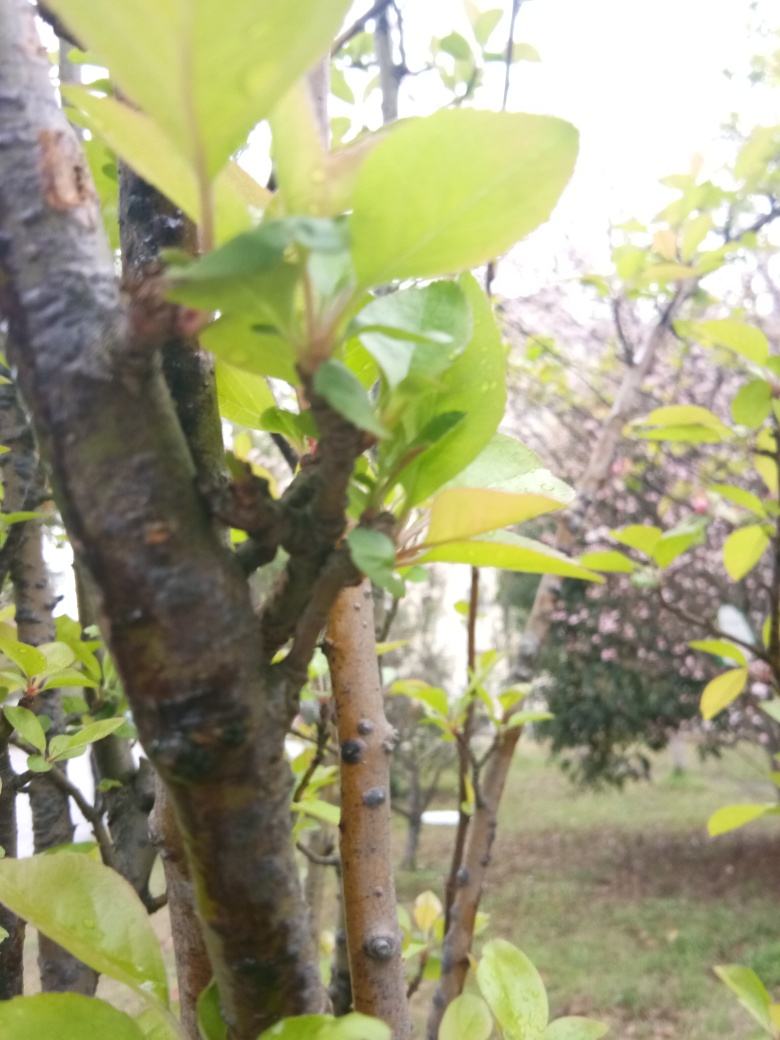Has the image lost all fine details? While some details are not clearly visible due to the shallow depth of field and the focus being on the foreground, the image still retains a level of detail, particularly in the leaves and branches that are in focus. There's a discernible texture on the tree bark and the moisture on the leaves that suggests a recent rainfall or dew. 